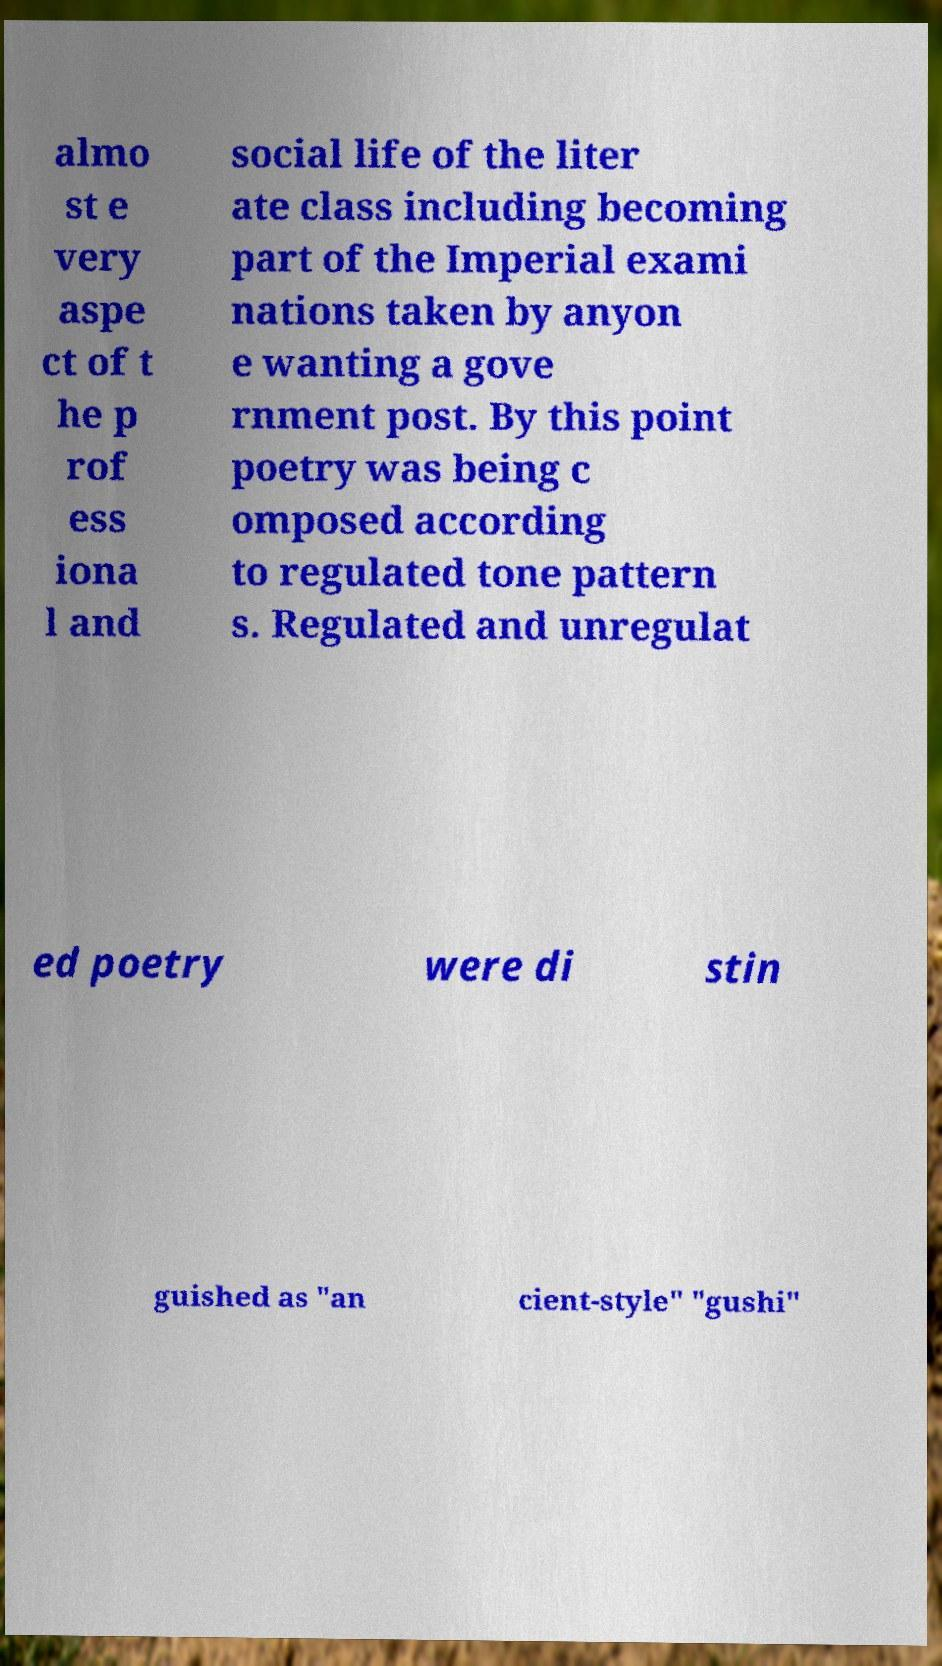Can you accurately transcribe the text from the provided image for me? almo st e very aspe ct of t he p rof ess iona l and social life of the liter ate class including becoming part of the Imperial exami nations taken by anyon e wanting a gove rnment post. By this point poetry was being c omposed according to regulated tone pattern s. Regulated and unregulat ed poetry were di stin guished as "an cient-style" "gushi" 